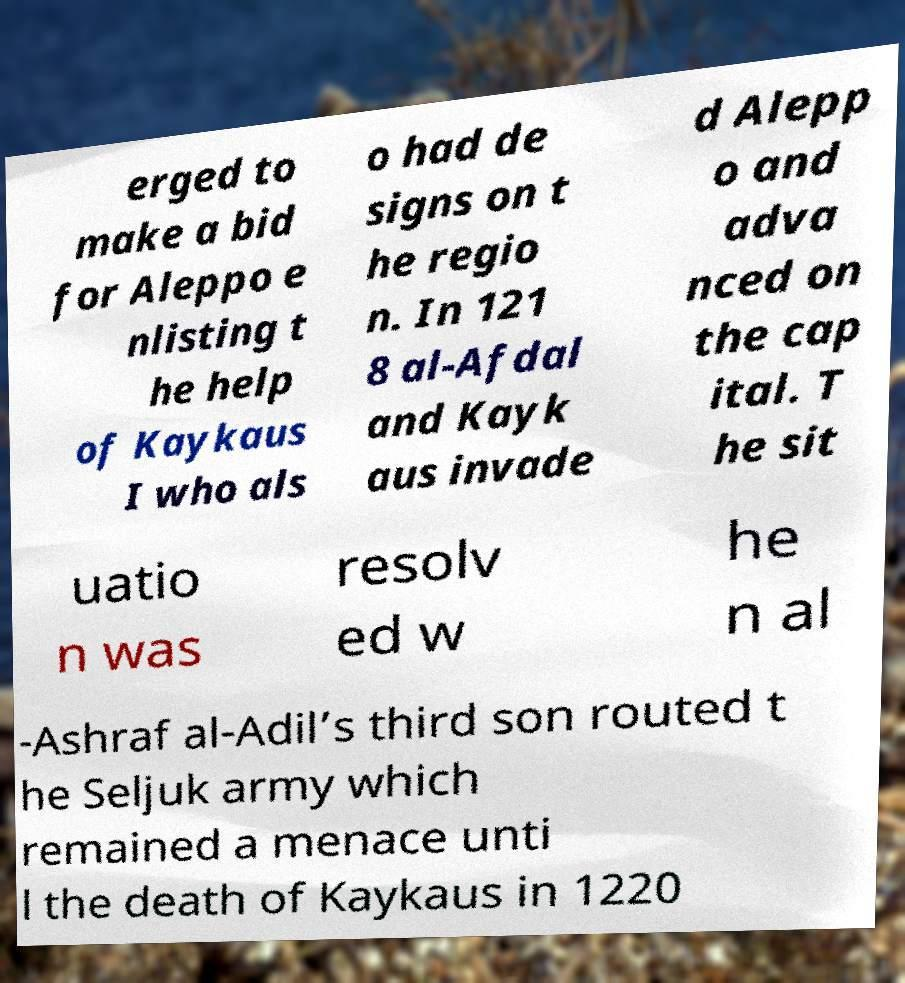What messages or text are displayed in this image? I need them in a readable, typed format. erged to make a bid for Aleppo e nlisting t he help of Kaykaus I who als o had de signs on t he regio n. In 121 8 al-Afdal and Kayk aus invade d Alepp o and adva nced on the cap ital. T he sit uatio n was resolv ed w he n al -Ashraf al-Adil’s third son routed t he Seljuk army which remained a menace unti l the death of Kaykaus in 1220 